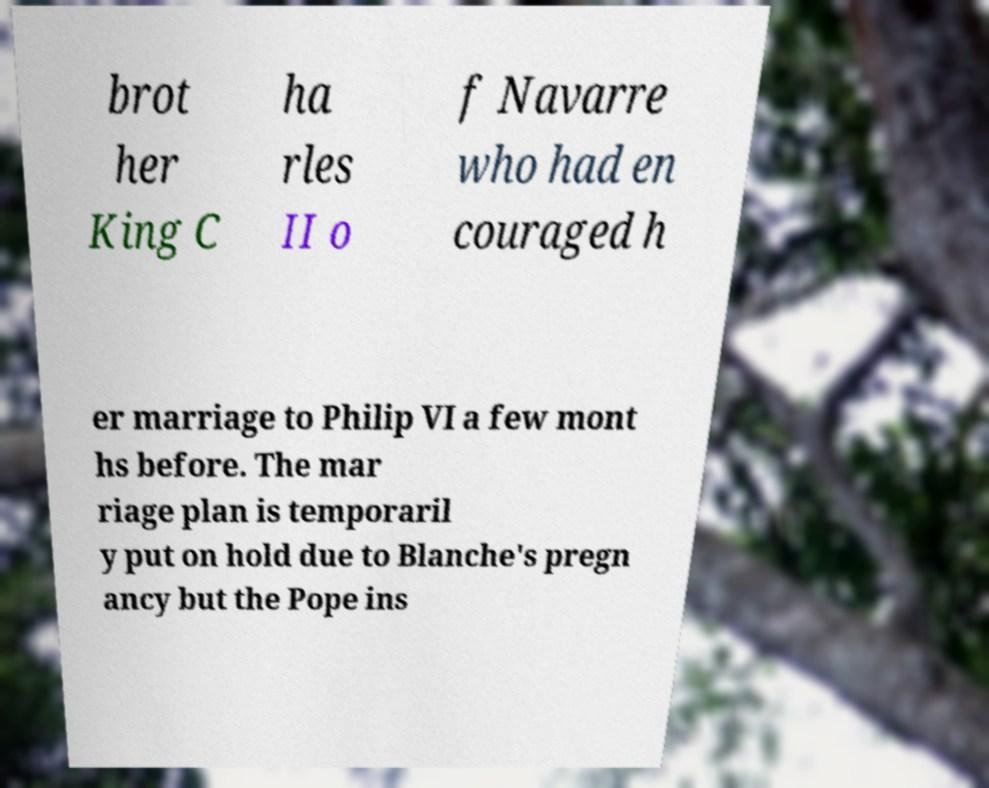Could you assist in decoding the text presented in this image and type it out clearly? brot her King C ha rles II o f Navarre who had en couraged h er marriage to Philip VI a few mont hs before. The mar riage plan is temporaril y put on hold due to Blanche's pregn ancy but the Pope ins 